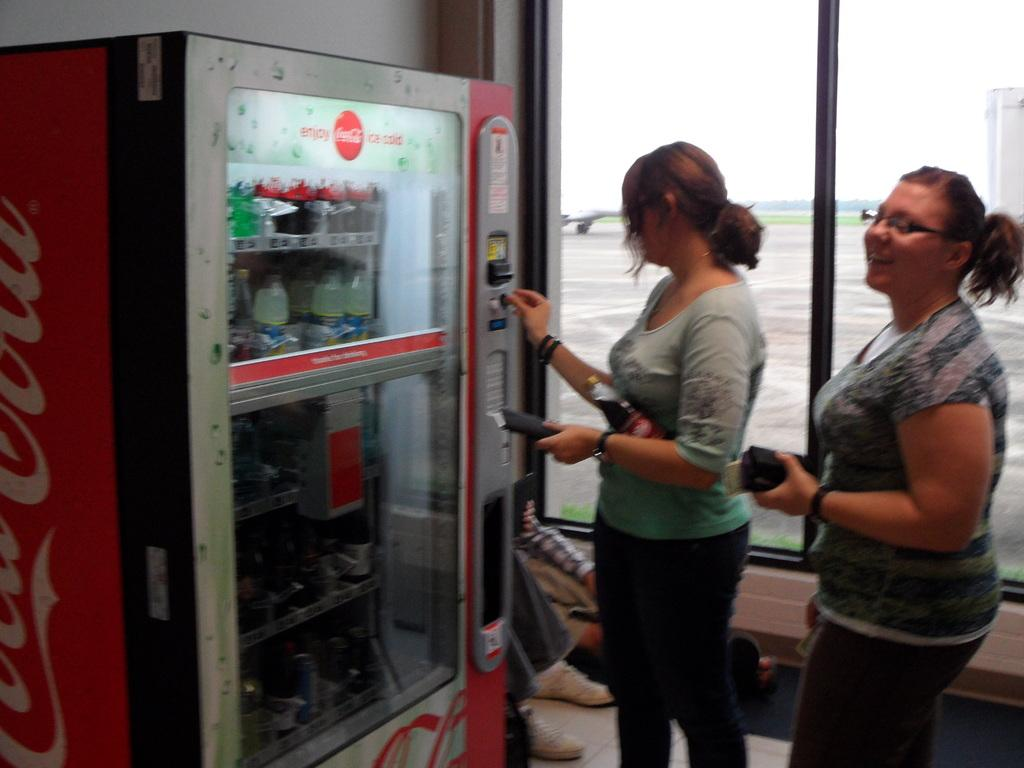<image>
Write a terse but informative summary of the picture. A woman puts coins into a Coca Cola vending machine. 